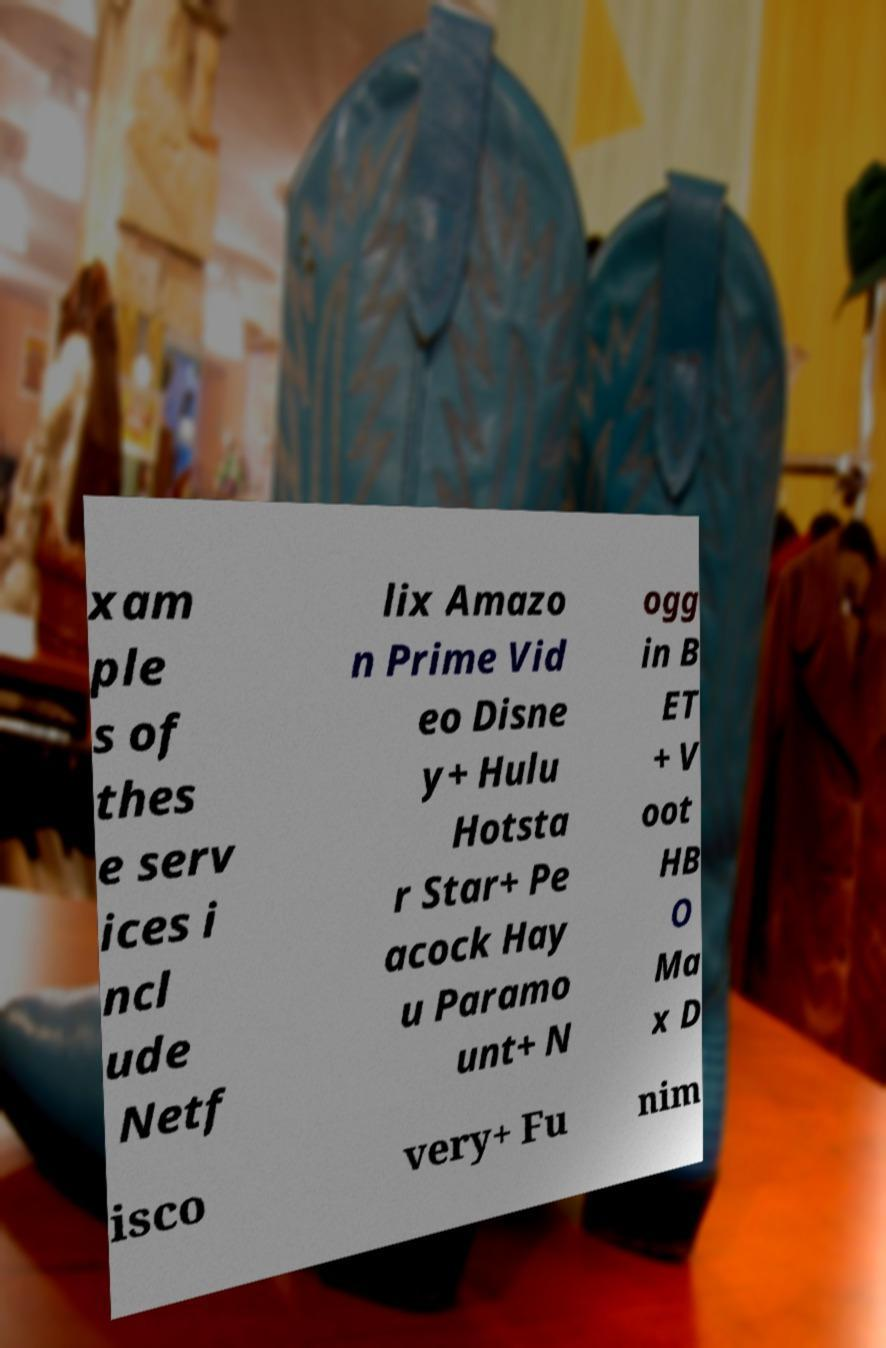There's text embedded in this image that I need extracted. Can you transcribe it verbatim? xam ple s of thes e serv ices i ncl ude Netf lix Amazo n Prime Vid eo Disne y+ Hulu Hotsta r Star+ Pe acock Hay u Paramo unt+ N ogg in B ET + V oot HB O Ma x D isco very+ Fu nim 